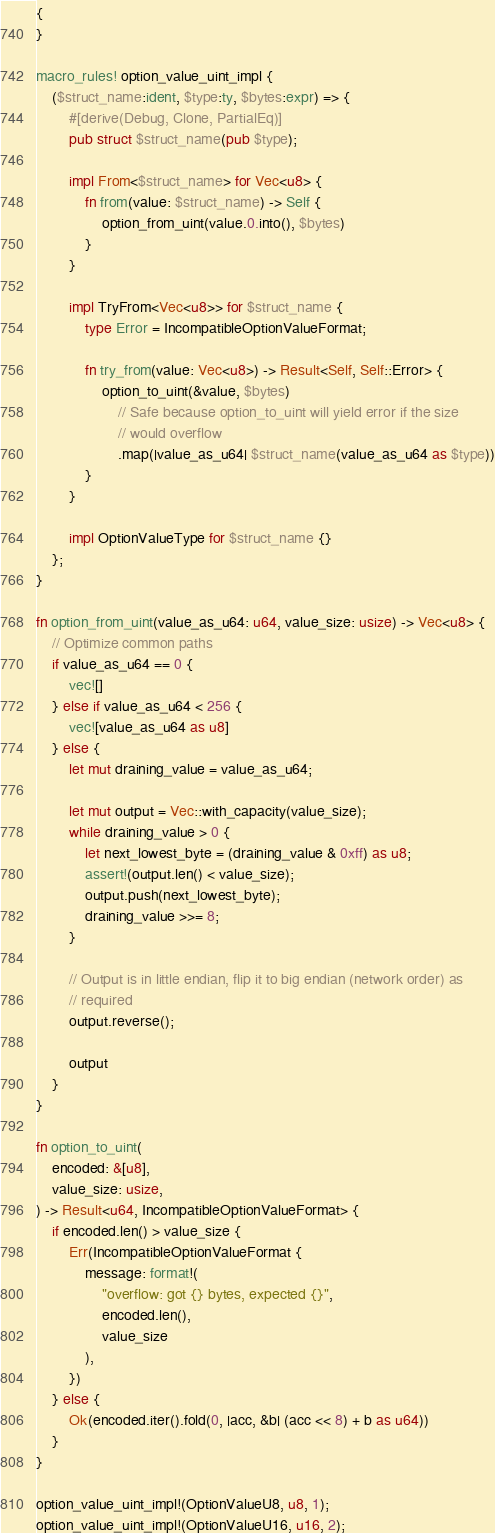Convert code to text. <code><loc_0><loc_0><loc_500><loc_500><_Rust_>{
}

macro_rules! option_value_uint_impl {
    ($struct_name:ident, $type:ty, $bytes:expr) => {
        #[derive(Debug, Clone, PartialEq)]
        pub struct $struct_name(pub $type);

        impl From<$struct_name> for Vec<u8> {
            fn from(value: $struct_name) -> Self {
                option_from_uint(value.0.into(), $bytes)
            }
        }

        impl TryFrom<Vec<u8>> for $struct_name {
            type Error = IncompatibleOptionValueFormat;

            fn try_from(value: Vec<u8>) -> Result<Self, Self::Error> {
                option_to_uint(&value, $bytes)
                    // Safe because option_to_uint will yield error if the size
                    // would overflow
                    .map(|value_as_u64| $struct_name(value_as_u64 as $type))
            }
        }

        impl OptionValueType for $struct_name {}
    };
}

fn option_from_uint(value_as_u64: u64, value_size: usize) -> Vec<u8> {
    // Optimize common paths
    if value_as_u64 == 0 {
        vec![]
    } else if value_as_u64 < 256 {
        vec![value_as_u64 as u8]
    } else {
        let mut draining_value = value_as_u64;

        let mut output = Vec::with_capacity(value_size);
        while draining_value > 0 {
            let next_lowest_byte = (draining_value & 0xff) as u8;
            assert!(output.len() < value_size);
            output.push(next_lowest_byte);
            draining_value >>= 8;
        }

        // Output is in little endian, flip it to big endian (network order) as
        // required
        output.reverse();

        output
    }
}

fn option_to_uint(
    encoded: &[u8],
    value_size: usize,
) -> Result<u64, IncompatibleOptionValueFormat> {
    if encoded.len() > value_size {
        Err(IncompatibleOptionValueFormat {
            message: format!(
                "overflow: got {} bytes, expected {}",
                encoded.len(),
                value_size
            ),
        })
    } else {
        Ok(encoded.iter().fold(0, |acc, &b| (acc << 8) + b as u64))
    }
}

option_value_uint_impl!(OptionValueU8, u8, 1);
option_value_uint_impl!(OptionValueU16, u16, 2);</code> 